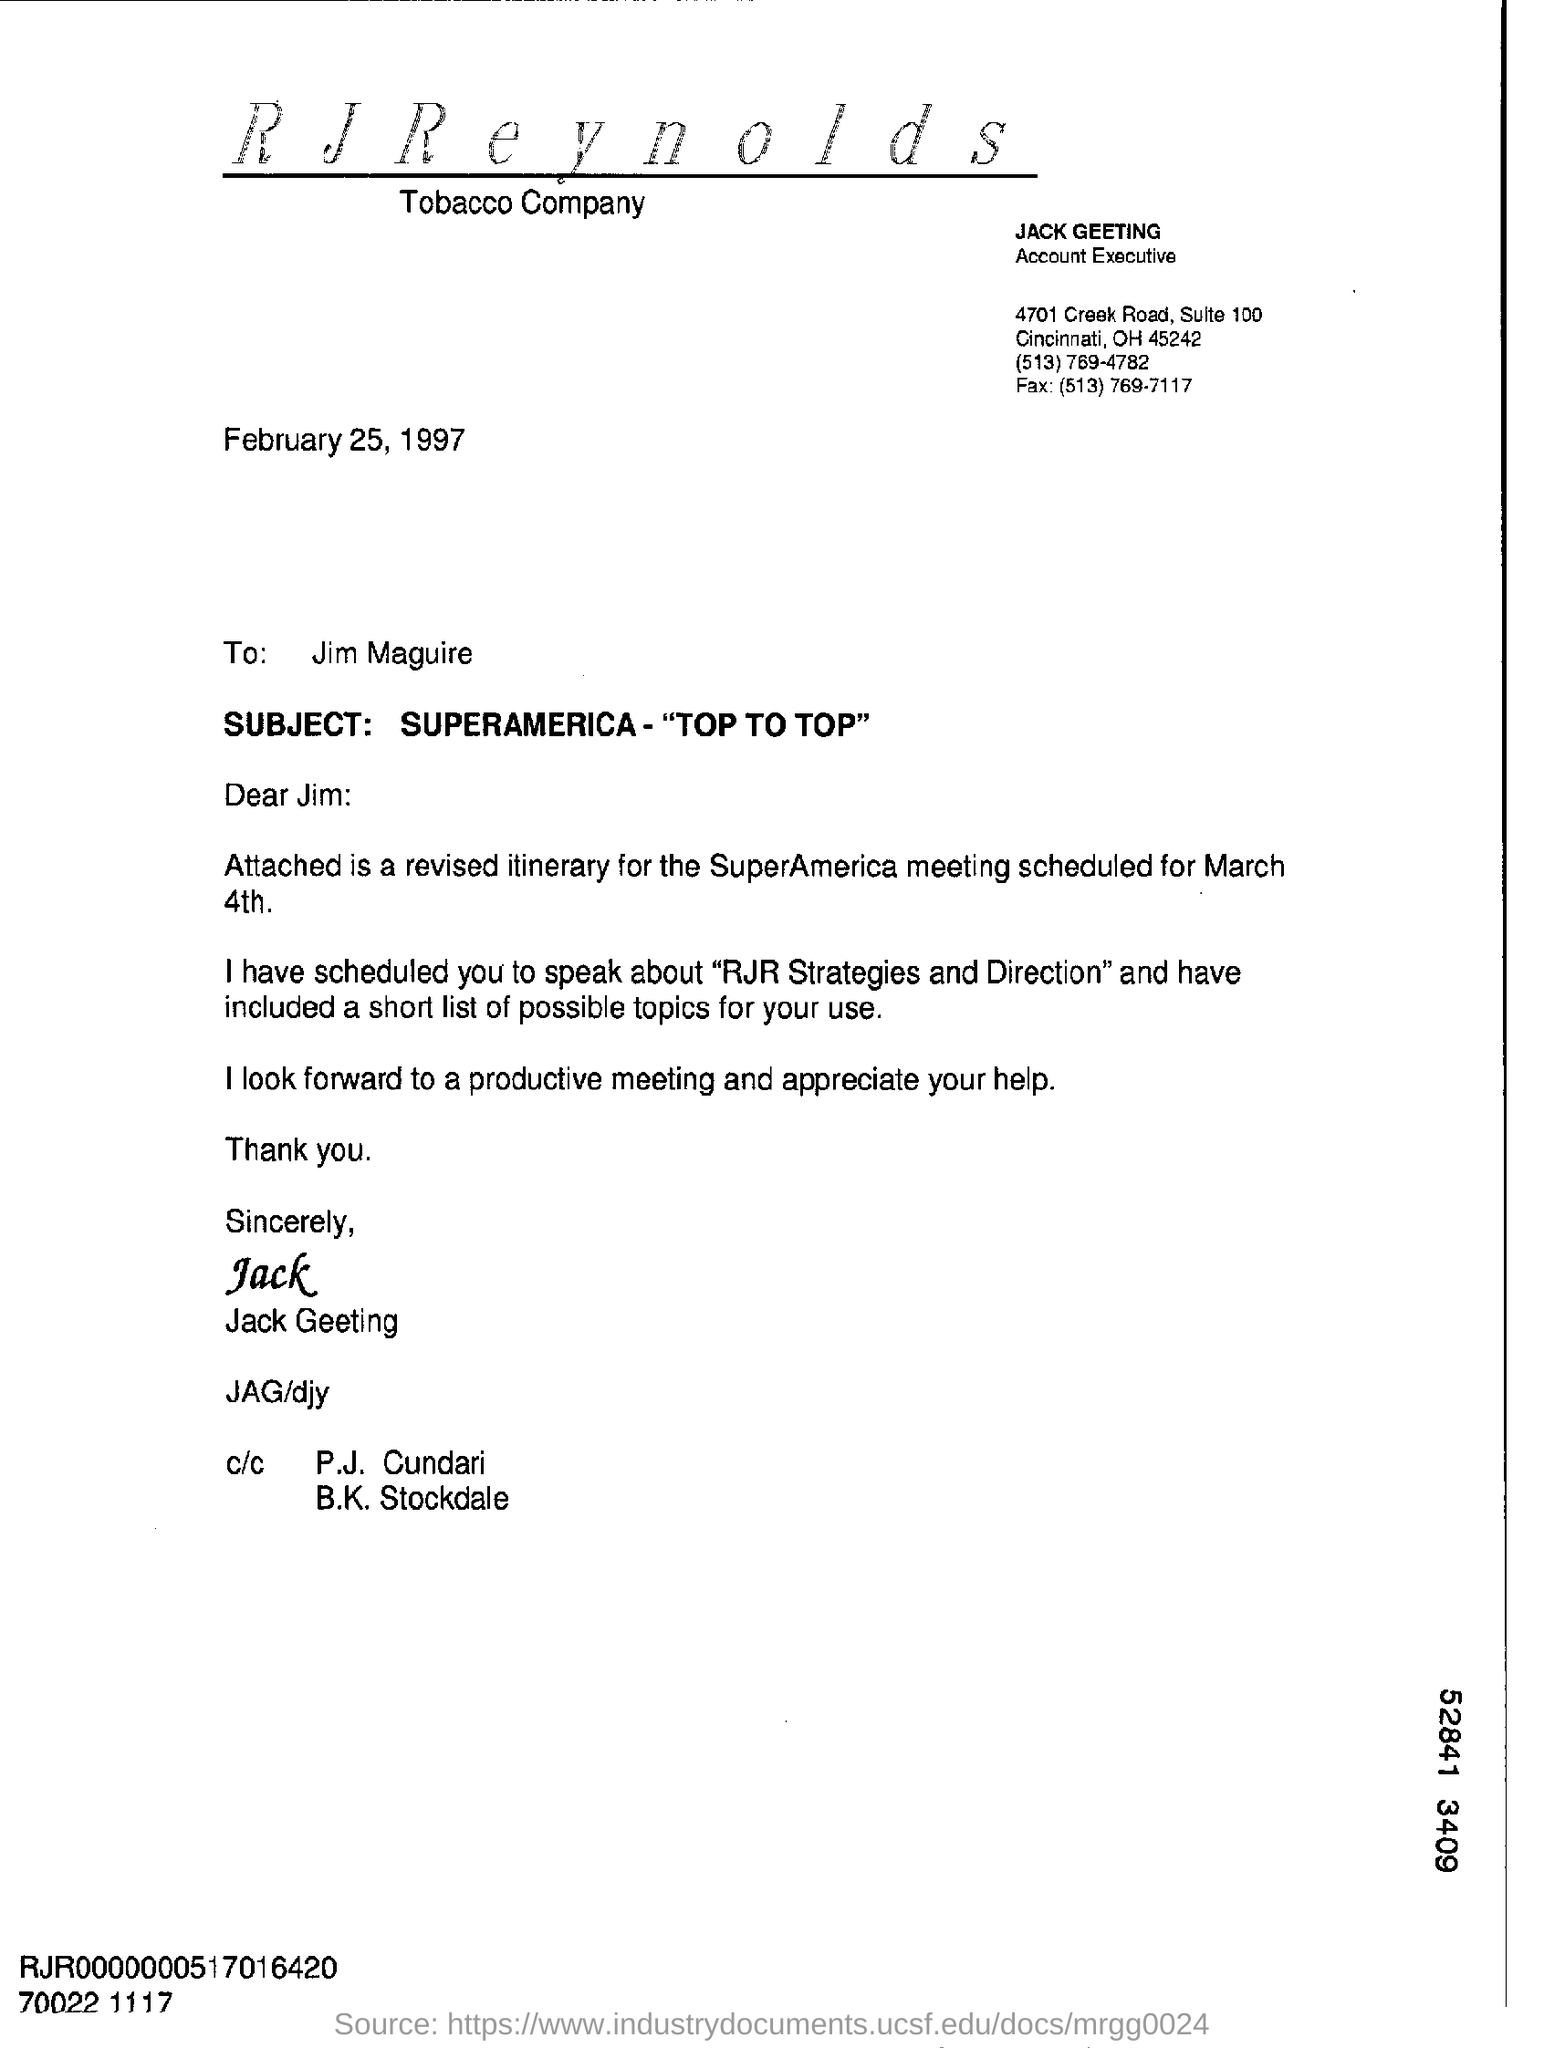What document is attached?
Your answer should be compact. Revised Itinerary. What is "salutation" used in this correspondence?
Provide a succinct answer. Dear Jim:. Which companys name is given in the letterhead?
Give a very brief answer. RJ Reynolds tobacco company. Who wrote this letter?
Keep it short and to the point. Jack Geeting. What is the designation of Jack Greeting?
Your answer should be very brief. Account Executive. What is suite no: of the company?
Provide a succinct answer. 100. What is date on which this document is sent?
Your answer should be very brief. February 25, 1997. Whom this letter is addressed to?
Make the answer very short. Jim Maguire. What is the subject of this letter?
Your answer should be very brief. Superamerica- "Top to Top". 